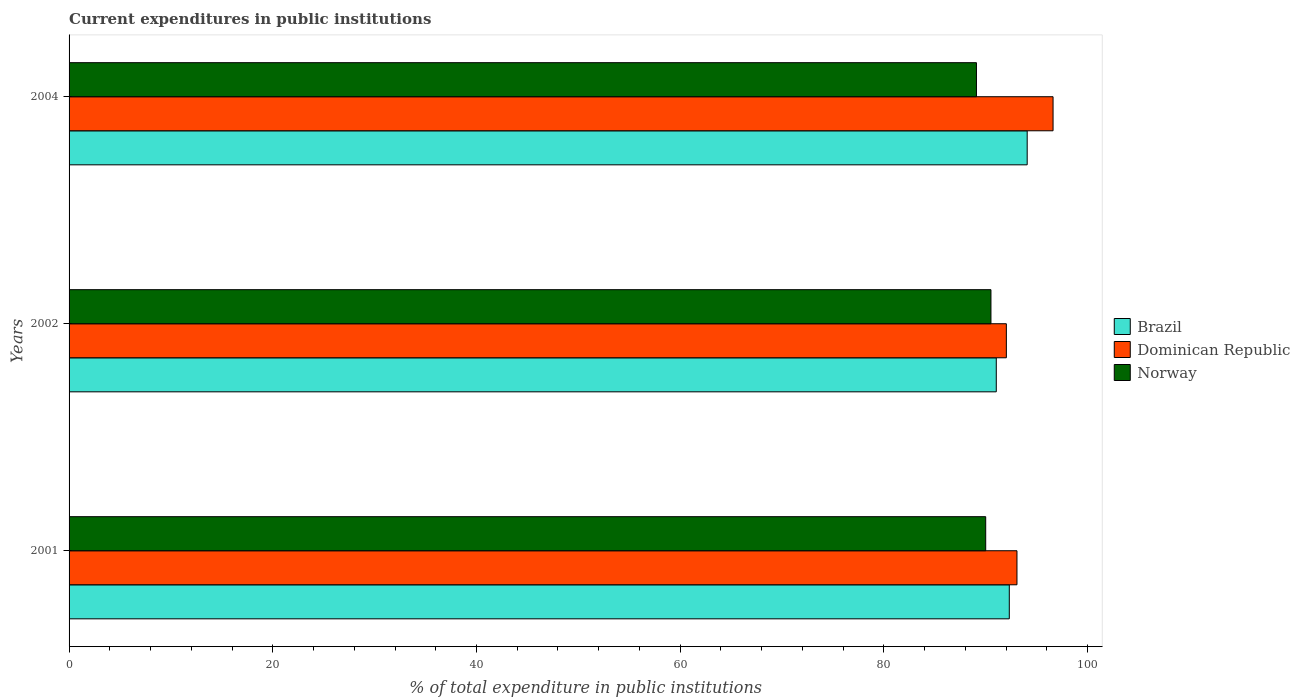How many different coloured bars are there?
Give a very brief answer. 3. Are the number of bars per tick equal to the number of legend labels?
Offer a very short reply. Yes. How many bars are there on the 3rd tick from the bottom?
Provide a succinct answer. 3. What is the label of the 1st group of bars from the top?
Give a very brief answer. 2004. What is the current expenditures in public institutions in Dominican Republic in 2001?
Offer a terse response. 93.06. Across all years, what is the maximum current expenditures in public institutions in Norway?
Offer a terse response. 90.51. Across all years, what is the minimum current expenditures in public institutions in Dominican Republic?
Keep it short and to the point. 92.02. In which year was the current expenditures in public institutions in Brazil maximum?
Provide a succinct answer. 2004. In which year was the current expenditures in public institutions in Dominican Republic minimum?
Your answer should be compact. 2002. What is the total current expenditures in public institutions in Dominican Republic in the graph?
Your response must be concise. 281.69. What is the difference between the current expenditures in public institutions in Norway in 2001 and that in 2002?
Your response must be concise. -0.52. What is the difference between the current expenditures in public institutions in Norway in 2004 and the current expenditures in public institutions in Brazil in 2002?
Your answer should be compact. -1.95. What is the average current expenditures in public institutions in Dominican Republic per year?
Provide a short and direct response. 93.9. In the year 2002, what is the difference between the current expenditures in public institutions in Brazil and current expenditures in public institutions in Dominican Republic?
Your response must be concise. -0.99. What is the ratio of the current expenditures in public institutions in Dominican Republic in 2002 to that in 2004?
Provide a short and direct response. 0.95. Is the difference between the current expenditures in public institutions in Brazil in 2001 and 2004 greater than the difference between the current expenditures in public institutions in Dominican Republic in 2001 and 2004?
Your response must be concise. Yes. What is the difference between the highest and the second highest current expenditures in public institutions in Brazil?
Provide a short and direct response. 1.76. What is the difference between the highest and the lowest current expenditures in public institutions in Dominican Republic?
Keep it short and to the point. 4.59. In how many years, is the current expenditures in public institutions in Dominican Republic greater than the average current expenditures in public institutions in Dominican Republic taken over all years?
Offer a terse response. 1. What does the 2nd bar from the top in 2002 represents?
Your response must be concise. Dominican Republic. What does the 2nd bar from the bottom in 2002 represents?
Keep it short and to the point. Dominican Republic. How many bars are there?
Make the answer very short. 9. Are all the bars in the graph horizontal?
Your answer should be compact. Yes. How many years are there in the graph?
Make the answer very short. 3. Does the graph contain any zero values?
Keep it short and to the point. No. How are the legend labels stacked?
Provide a succinct answer. Vertical. What is the title of the graph?
Your answer should be compact. Current expenditures in public institutions. Does "Iraq" appear as one of the legend labels in the graph?
Provide a succinct answer. No. What is the label or title of the X-axis?
Offer a very short reply. % of total expenditure in public institutions. What is the label or title of the Y-axis?
Make the answer very short. Years. What is the % of total expenditure in public institutions in Brazil in 2001?
Provide a succinct answer. 92.31. What is the % of total expenditure in public institutions of Dominican Republic in 2001?
Ensure brevity in your answer.  93.06. What is the % of total expenditure in public institutions in Norway in 2001?
Provide a short and direct response. 89.99. What is the % of total expenditure in public institutions of Brazil in 2002?
Make the answer very short. 91.03. What is the % of total expenditure in public institutions of Dominican Republic in 2002?
Your response must be concise. 92.02. What is the % of total expenditure in public institutions in Norway in 2002?
Make the answer very short. 90.51. What is the % of total expenditure in public institutions of Brazil in 2004?
Your answer should be very brief. 94.07. What is the % of total expenditure in public institutions of Dominican Republic in 2004?
Give a very brief answer. 96.61. What is the % of total expenditure in public institutions in Norway in 2004?
Provide a succinct answer. 89.09. Across all years, what is the maximum % of total expenditure in public institutions of Brazil?
Keep it short and to the point. 94.07. Across all years, what is the maximum % of total expenditure in public institutions in Dominican Republic?
Give a very brief answer. 96.61. Across all years, what is the maximum % of total expenditure in public institutions in Norway?
Offer a very short reply. 90.51. Across all years, what is the minimum % of total expenditure in public institutions in Brazil?
Your answer should be very brief. 91.03. Across all years, what is the minimum % of total expenditure in public institutions of Dominican Republic?
Give a very brief answer. 92.02. Across all years, what is the minimum % of total expenditure in public institutions in Norway?
Keep it short and to the point. 89.09. What is the total % of total expenditure in public institutions in Brazil in the graph?
Provide a succinct answer. 277.41. What is the total % of total expenditure in public institutions in Dominican Republic in the graph?
Make the answer very short. 281.69. What is the total % of total expenditure in public institutions of Norway in the graph?
Your answer should be very brief. 269.59. What is the difference between the % of total expenditure in public institutions in Brazil in 2001 and that in 2002?
Offer a terse response. 1.28. What is the difference between the % of total expenditure in public institutions in Dominican Republic in 2001 and that in 2002?
Offer a very short reply. 1.04. What is the difference between the % of total expenditure in public institutions of Norway in 2001 and that in 2002?
Ensure brevity in your answer.  -0.52. What is the difference between the % of total expenditure in public institutions of Brazil in 2001 and that in 2004?
Offer a very short reply. -1.76. What is the difference between the % of total expenditure in public institutions of Dominican Republic in 2001 and that in 2004?
Your response must be concise. -3.54. What is the difference between the % of total expenditure in public institutions in Norway in 2001 and that in 2004?
Provide a succinct answer. 0.91. What is the difference between the % of total expenditure in public institutions of Brazil in 2002 and that in 2004?
Make the answer very short. -3.03. What is the difference between the % of total expenditure in public institutions of Dominican Republic in 2002 and that in 2004?
Keep it short and to the point. -4.59. What is the difference between the % of total expenditure in public institutions in Norway in 2002 and that in 2004?
Keep it short and to the point. 1.42. What is the difference between the % of total expenditure in public institutions in Brazil in 2001 and the % of total expenditure in public institutions in Dominican Republic in 2002?
Provide a succinct answer. 0.29. What is the difference between the % of total expenditure in public institutions of Brazil in 2001 and the % of total expenditure in public institutions of Norway in 2002?
Give a very brief answer. 1.8. What is the difference between the % of total expenditure in public institutions of Dominican Republic in 2001 and the % of total expenditure in public institutions of Norway in 2002?
Make the answer very short. 2.56. What is the difference between the % of total expenditure in public institutions of Brazil in 2001 and the % of total expenditure in public institutions of Dominican Republic in 2004?
Provide a short and direct response. -4.3. What is the difference between the % of total expenditure in public institutions of Brazil in 2001 and the % of total expenditure in public institutions of Norway in 2004?
Make the answer very short. 3.22. What is the difference between the % of total expenditure in public institutions in Dominican Republic in 2001 and the % of total expenditure in public institutions in Norway in 2004?
Ensure brevity in your answer.  3.98. What is the difference between the % of total expenditure in public institutions in Brazil in 2002 and the % of total expenditure in public institutions in Dominican Republic in 2004?
Your response must be concise. -5.57. What is the difference between the % of total expenditure in public institutions of Brazil in 2002 and the % of total expenditure in public institutions of Norway in 2004?
Provide a short and direct response. 1.95. What is the difference between the % of total expenditure in public institutions in Dominican Republic in 2002 and the % of total expenditure in public institutions in Norway in 2004?
Provide a succinct answer. 2.94. What is the average % of total expenditure in public institutions in Brazil per year?
Provide a succinct answer. 92.47. What is the average % of total expenditure in public institutions in Dominican Republic per year?
Provide a succinct answer. 93.9. What is the average % of total expenditure in public institutions in Norway per year?
Your answer should be very brief. 89.86. In the year 2001, what is the difference between the % of total expenditure in public institutions in Brazil and % of total expenditure in public institutions in Dominican Republic?
Offer a terse response. -0.75. In the year 2001, what is the difference between the % of total expenditure in public institutions in Brazil and % of total expenditure in public institutions in Norway?
Your answer should be compact. 2.32. In the year 2001, what is the difference between the % of total expenditure in public institutions of Dominican Republic and % of total expenditure in public institutions of Norway?
Provide a short and direct response. 3.07. In the year 2002, what is the difference between the % of total expenditure in public institutions of Brazil and % of total expenditure in public institutions of Dominican Republic?
Give a very brief answer. -0.99. In the year 2002, what is the difference between the % of total expenditure in public institutions of Brazil and % of total expenditure in public institutions of Norway?
Keep it short and to the point. 0.52. In the year 2002, what is the difference between the % of total expenditure in public institutions of Dominican Republic and % of total expenditure in public institutions of Norway?
Keep it short and to the point. 1.51. In the year 2004, what is the difference between the % of total expenditure in public institutions of Brazil and % of total expenditure in public institutions of Dominican Republic?
Give a very brief answer. -2.54. In the year 2004, what is the difference between the % of total expenditure in public institutions in Brazil and % of total expenditure in public institutions in Norway?
Provide a succinct answer. 4.98. In the year 2004, what is the difference between the % of total expenditure in public institutions of Dominican Republic and % of total expenditure in public institutions of Norway?
Ensure brevity in your answer.  7.52. What is the ratio of the % of total expenditure in public institutions of Brazil in 2001 to that in 2002?
Your answer should be very brief. 1.01. What is the ratio of the % of total expenditure in public institutions in Dominican Republic in 2001 to that in 2002?
Provide a short and direct response. 1.01. What is the ratio of the % of total expenditure in public institutions of Brazil in 2001 to that in 2004?
Offer a terse response. 0.98. What is the ratio of the % of total expenditure in public institutions of Dominican Republic in 2001 to that in 2004?
Ensure brevity in your answer.  0.96. What is the ratio of the % of total expenditure in public institutions in Norway in 2001 to that in 2004?
Provide a short and direct response. 1.01. What is the ratio of the % of total expenditure in public institutions of Brazil in 2002 to that in 2004?
Ensure brevity in your answer.  0.97. What is the ratio of the % of total expenditure in public institutions of Dominican Republic in 2002 to that in 2004?
Make the answer very short. 0.95. What is the ratio of the % of total expenditure in public institutions in Norway in 2002 to that in 2004?
Ensure brevity in your answer.  1.02. What is the difference between the highest and the second highest % of total expenditure in public institutions of Brazil?
Make the answer very short. 1.76. What is the difference between the highest and the second highest % of total expenditure in public institutions in Dominican Republic?
Ensure brevity in your answer.  3.54. What is the difference between the highest and the second highest % of total expenditure in public institutions of Norway?
Ensure brevity in your answer.  0.52. What is the difference between the highest and the lowest % of total expenditure in public institutions in Brazil?
Make the answer very short. 3.03. What is the difference between the highest and the lowest % of total expenditure in public institutions of Dominican Republic?
Your answer should be compact. 4.59. What is the difference between the highest and the lowest % of total expenditure in public institutions in Norway?
Make the answer very short. 1.42. 